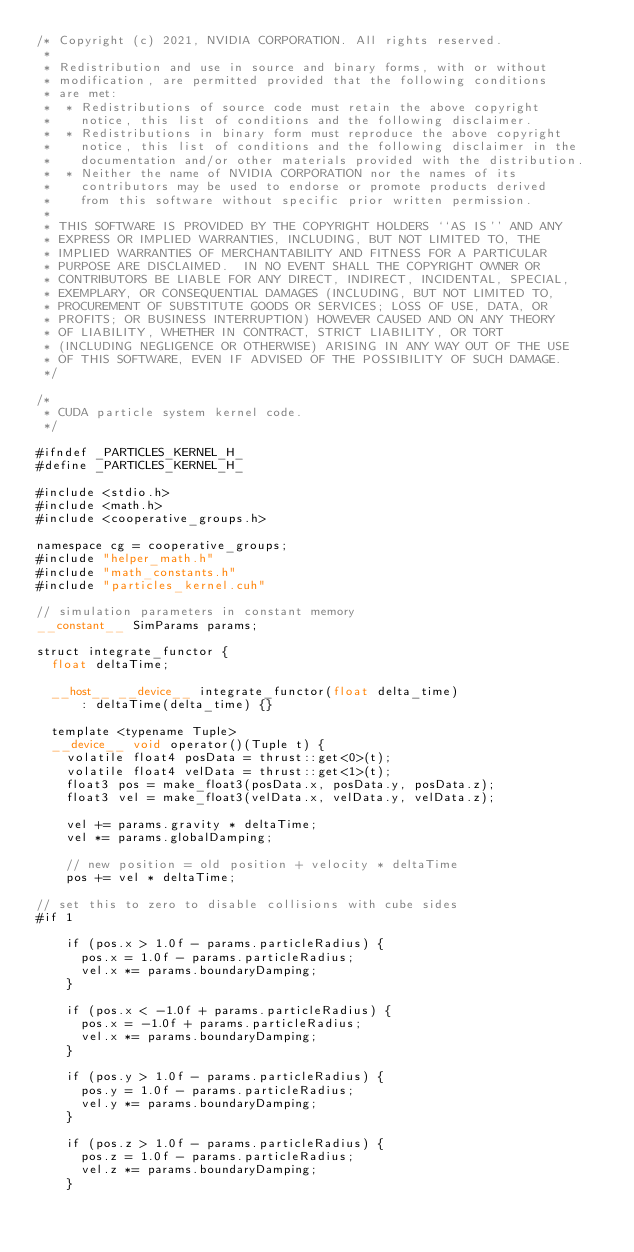Convert code to text. <code><loc_0><loc_0><loc_500><loc_500><_Cuda_>/* Copyright (c) 2021, NVIDIA CORPORATION. All rights reserved.
 *
 * Redistribution and use in source and binary forms, with or without
 * modification, are permitted provided that the following conditions
 * are met:
 *  * Redistributions of source code must retain the above copyright
 *    notice, this list of conditions and the following disclaimer.
 *  * Redistributions in binary form must reproduce the above copyright
 *    notice, this list of conditions and the following disclaimer in the
 *    documentation and/or other materials provided with the distribution.
 *  * Neither the name of NVIDIA CORPORATION nor the names of its
 *    contributors may be used to endorse or promote products derived
 *    from this software without specific prior written permission.
 *
 * THIS SOFTWARE IS PROVIDED BY THE COPYRIGHT HOLDERS ``AS IS'' AND ANY
 * EXPRESS OR IMPLIED WARRANTIES, INCLUDING, BUT NOT LIMITED TO, THE
 * IMPLIED WARRANTIES OF MERCHANTABILITY AND FITNESS FOR A PARTICULAR
 * PURPOSE ARE DISCLAIMED.  IN NO EVENT SHALL THE COPYRIGHT OWNER OR
 * CONTRIBUTORS BE LIABLE FOR ANY DIRECT, INDIRECT, INCIDENTAL, SPECIAL,
 * EXEMPLARY, OR CONSEQUENTIAL DAMAGES (INCLUDING, BUT NOT LIMITED TO,
 * PROCUREMENT OF SUBSTITUTE GOODS OR SERVICES; LOSS OF USE, DATA, OR
 * PROFITS; OR BUSINESS INTERRUPTION) HOWEVER CAUSED AND ON ANY THEORY
 * OF LIABILITY, WHETHER IN CONTRACT, STRICT LIABILITY, OR TORT
 * (INCLUDING NEGLIGENCE OR OTHERWISE) ARISING IN ANY WAY OUT OF THE USE
 * OF THIS SOFTWARE, EVEN IF ADVISED OF THE POSSIBILITY OF SUCH DAMAGE.
 */

/*
 * CUDA particle system kernel code.
 */

#ifndef _PARTICLES_KERNEL_H_
#define _PARTICLES_KERNEL_H_

#include <stdio.h>
#include <math.h>
#include <cooperative_groups.h>

namespace cg = cooperative_groups;
#include "helper_math.h"
#include "math_constants.h"
#include "particles_kernel.cuh"

// simulation parameters in constant memory
__constant__ SimParams params;

struct integrate_functor {
  float deltaTime;

  __host__ __device__ integrate_functor(float delta_time)
      : deltaTime(delta_time) {}

  template <typename Tuple>
  __device__ void operator()(Tuple t) {
    volatile float4 posData = thrust::get<0>(t);
    volatile float4 velData = thrust::get<1>(t);
    float3 pos = make_float3(posData.x, posData.y, posData.z);
    float3 vel = make_float3(velData.x, velData.y, velData.z);

    vel += params.gravity * deltaTime;
    vel *= params.globalDamping;

    // new position = old position + velocity * deltaTime
    pos += vel * deltaTime;

// set this to zero to disable collisions with cube sides
#if 1

    if (pos.x > 1.0f - params.particleRadius) {
      pos.x = 1.0f - params.particleRadius;
      vel.x *= params.boundaryDamping;
    }

    if (pos.x < -1.0f + params.particleRadius) {
      pos.x = -1.0f + params.particleRadius;
      vel.x *= params.boundaryDamping;
    }

    if (pos.y > 1.0f - params.particleRadius) {
      pos.y = 1.0f - params.particleRadius;
      vel.y *= params.boundaryDamping;
    }

    if (pos.z > 1.0f - params.particleRadius) {
      pos.z = 1.0f - params.particleRadius;
      vel.z *= params.boundaryDamping;
    }
</code> 